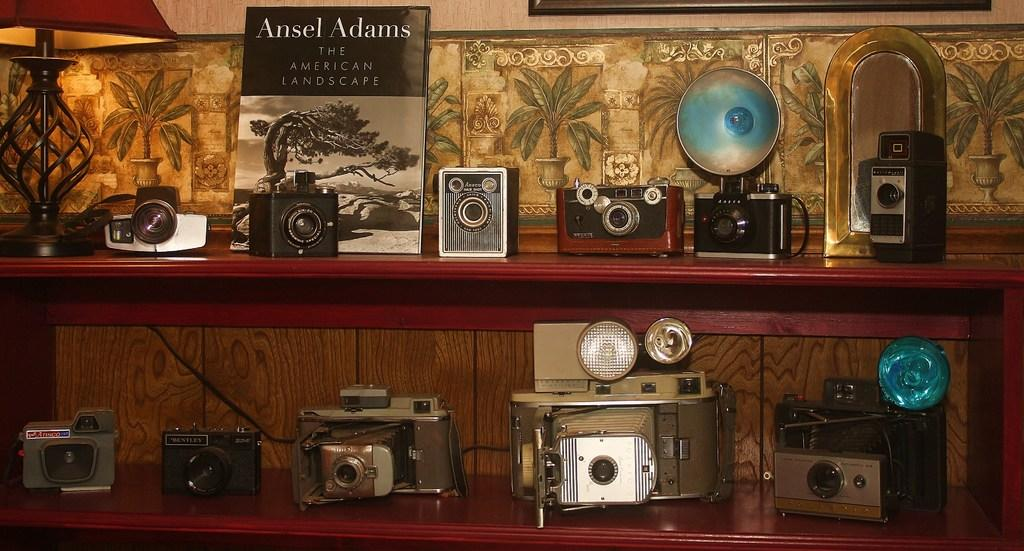<image>
Present a compact description of the photo's key features. Camera in front of a book which says Ansel Adams on the top. 